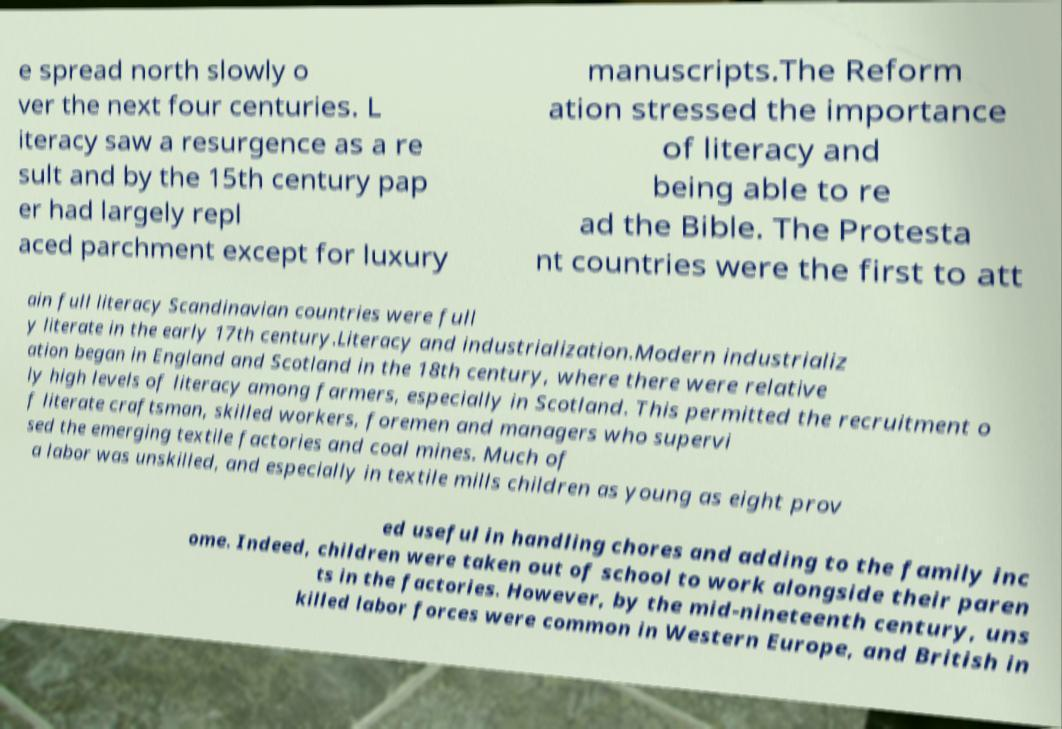Please identify and transcribe the text found in this image. e spread north slowly o ver the next four centuries. L iteracy saw a resurgence as a re sult and by the 15th century pap er had largely repl aced parchment except for luxury manuscripts.The Reform ation stressed the importance of literacy and being able to re ad the Bible. The Protesta nt countries were the first to att ain full literacy Scandinavian countries were full y literate in the early 17th century.Literacy and industrialization.Modern industrializ ation began in England and Scotland in the 18th century, where there were relative ly high levels of literacy among farmers, especially in Scotland. This permitted the recruitment o f literate craftsman, skilled workers, foremen and managers who supervi sed the emerging textile factories and coal mines. Much of a labor was unskilled, and especially in textile mills children as young as eight prov ed useful in handling chores and adding to the family inc ome. Indeed, children were taken out of school to work alongside their paren ts in the factories. However, by the mid-nineteenth century, uns killed labor forces were common in Western Europe, and British in 